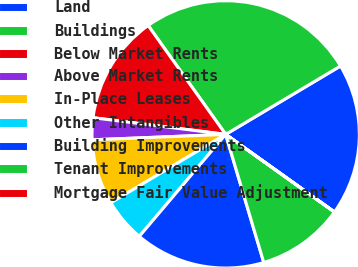<chart> <loc_0><loc_0><loc_500><loc_500><pie_chart><fcel>Land<fcel>Buildings<fcel>Below Market Rents<fcel>Above Market Rents<fcel>In-Place Leases<fcel>Other Intangibles<fcel>Building Improvements<fcel>Tenant Improvements<fcel>Mortgage Fair Value Adjustment<nl><fcel>18.41%<fcel>26.3%<fcel>13.16%<fcel>2.64%<fcel>7.9%<fcel>5.27%<fcel>15.78%<fcel>10.53%<fcel>0.01%<nl></chart> 